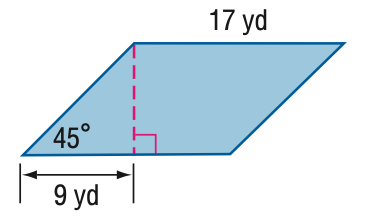Question: Find the area of the parallelogram. Round to the nearest tenth if necessary.
Choices:
A. 144.2
B. 153
C. 176.7
D. 288.5
Answer with the letter. Answer: B 